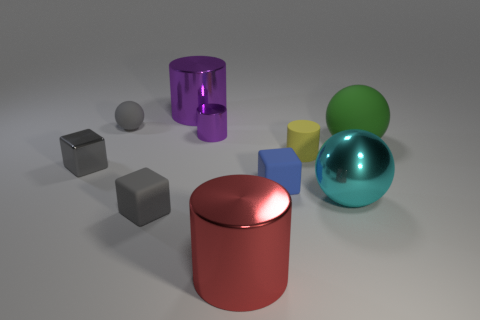Subtract all large purple shiny cylinders. How many cylinders are left? 3 Subtract all red cylinders. How many gray blocks are left? 2 Subtract all yellow cylinders. How many cylinders are left? 3 Subtract 2 blocks. How many blocks are left? 1 Subtract all spheres. How many objects are left? 7 Subtract all blocks. Subtract all blue objects. How many objects are left? 6 Add 9 large red cylinders. How many large red cylinders are left? 10 Add 6 yellow matte objects. How many yellow matte objects exist? 7 Subtract 0 brown cylinders. How many objects are left? 10 Subtract all brown cubes. Subtract all gray balls. How many cubes are left? 3 